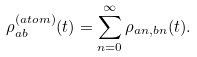<formula> <loc_0><loc_0><loc_500><loc_500>\rho _ { a b } ^ { ( a t o m ) } ( t ) = \sum _ { n = 0 } ^ { \infty } \rho _ { a n , b n } ( t ) .</formula> 